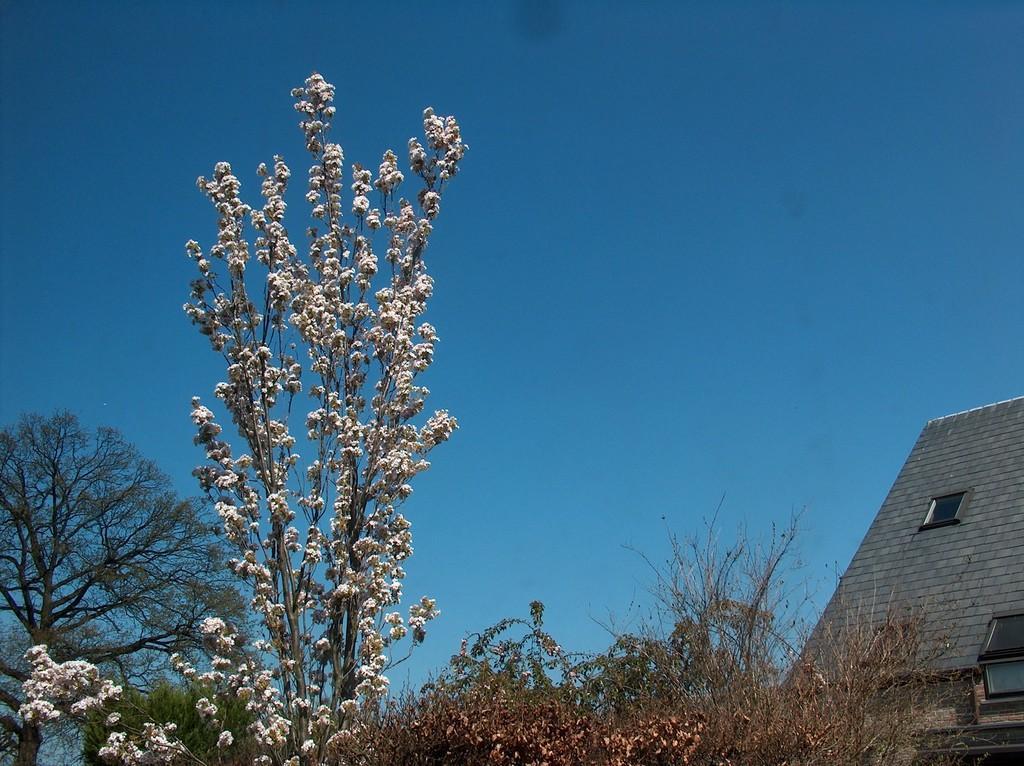In one or two sentences, can you explain what this image depicts? This image consists of trees. In the front, we can see white colored flowers. On the right, there is a building along with a window. At the top, there is sky. 